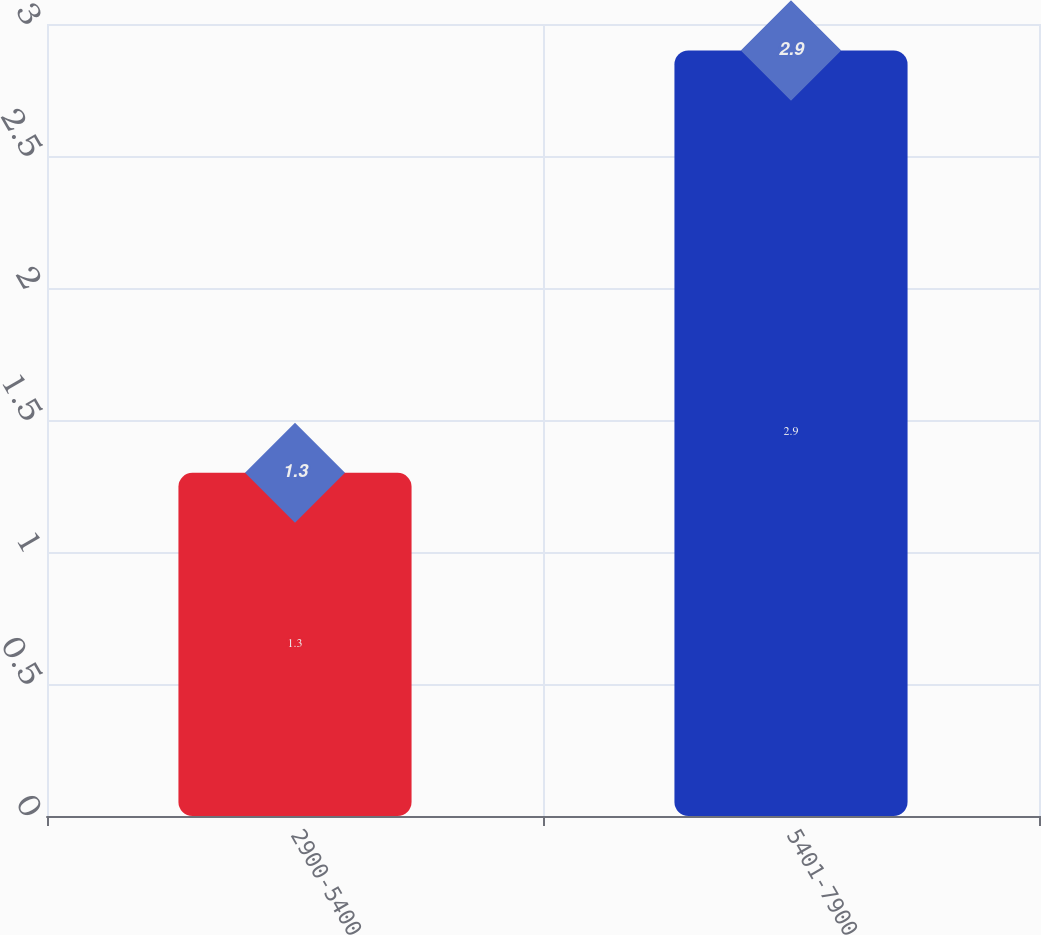Convert chart to OTSL. <chart><loc_0><loc_0><loc_500><loc_500><bar_chart><fcel>2900-5400<fcel>5401-7900<nl><fcel>1.3<fcel>2.9<nl></chart> 